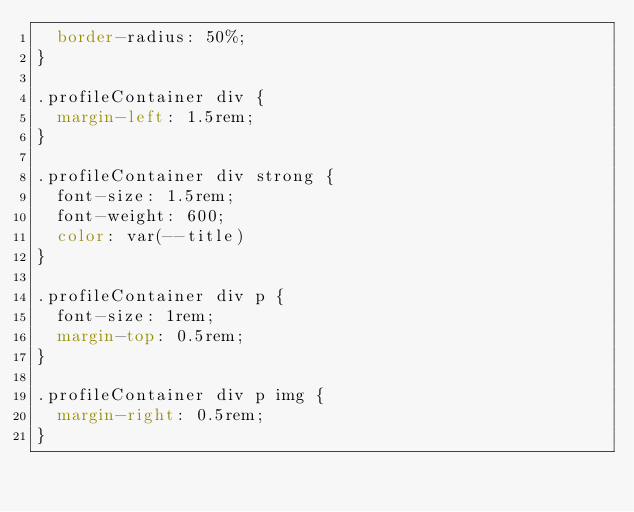Convert code to text. <code><loc_0><loc_0><loc_500><loc_500><_CSS_>	border-radius: 50%;
}

.profileContainer div {
	margin-left: 1.5rem;
}

.profileContainer div strong {
	font-size: 1.5rem;
	font-weight: 600;
	color: var(--title)
}

.profileContainer div p {
	font-size: 1rem;
	margin-top: 0.5rem;
}

.profileContainer div p img {
	margin-right: 0.5rem;
}
</code> 